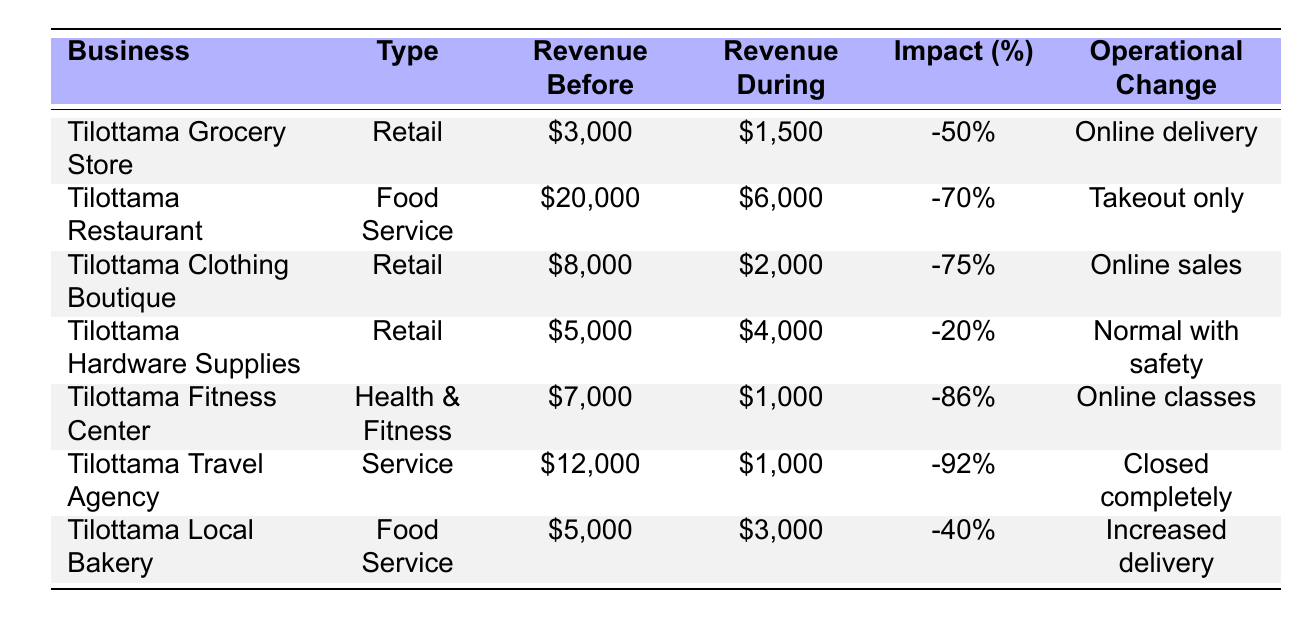What is the monthly revenue of the Tilottama Restaurant before COVID-19? The table states that the monthly revenue before COVID-19 for Tilottama Restaurant was $20,000.
Answer: $20,000 What percentage impact did the Tilottama Travel Agency experience during COVID-19? According to the table, Tilottama Travel Agency had an impact percentage of -92%.
Answer: -92% Which business had the highest impact percentage during COVID-19? By comparing the impact percentages, Tilottama Travel Agency had the highest impact with -92%.
Answer: Tilottama Travel Agency What is the total number of employees across all businesses listed? Counting the employees: 15 + 20 + 10 + 7 + 5 + 8 + 6 = 71. Therefore, the total number of employees is 71.
Answer: 71 How much support did the Tilottama Local Bakery receive? The table indicates that Tilottama Local Bakery received $700 in support during COVID-19.
Answer: $700 What operational change did the Tilottama Fitness Center make during COVID-19? The table notes that the Tilottama Fitness Center moved to online classes as its operational change during COVID-19.
Answer: Online classes What was the average monthly revenue during COVID-19 for all businesses? Calculating the total revenue during COVID-19: 1,500 + 6,000 + 2,000 + 4,000 + 1,000 + 1,000 + 3,000 = 18,500. There are 7 businesses, so the average is 18,500 / 7 = 2,642.86.
Answer: $2,642.86 Did any business see an increase in revenue during COVID-19 compared to before? By examining the table, all businesses reported a decrease in revenue during COVID-19 compared to their revenue before. Therefore, the answer is no.
Answer: No Which business had the least impact percentage during COVID-19? The business with the least impact percentage is Tilottama Hardware Supplies with an impact of -20%.
Answer: Tilottama Hardware Supplies What operational change did the Tilottama Grocery Store implement? The table shows the Tilottama Grocery Store introduced online delivery as its operational change.
Answer: Online delivery 